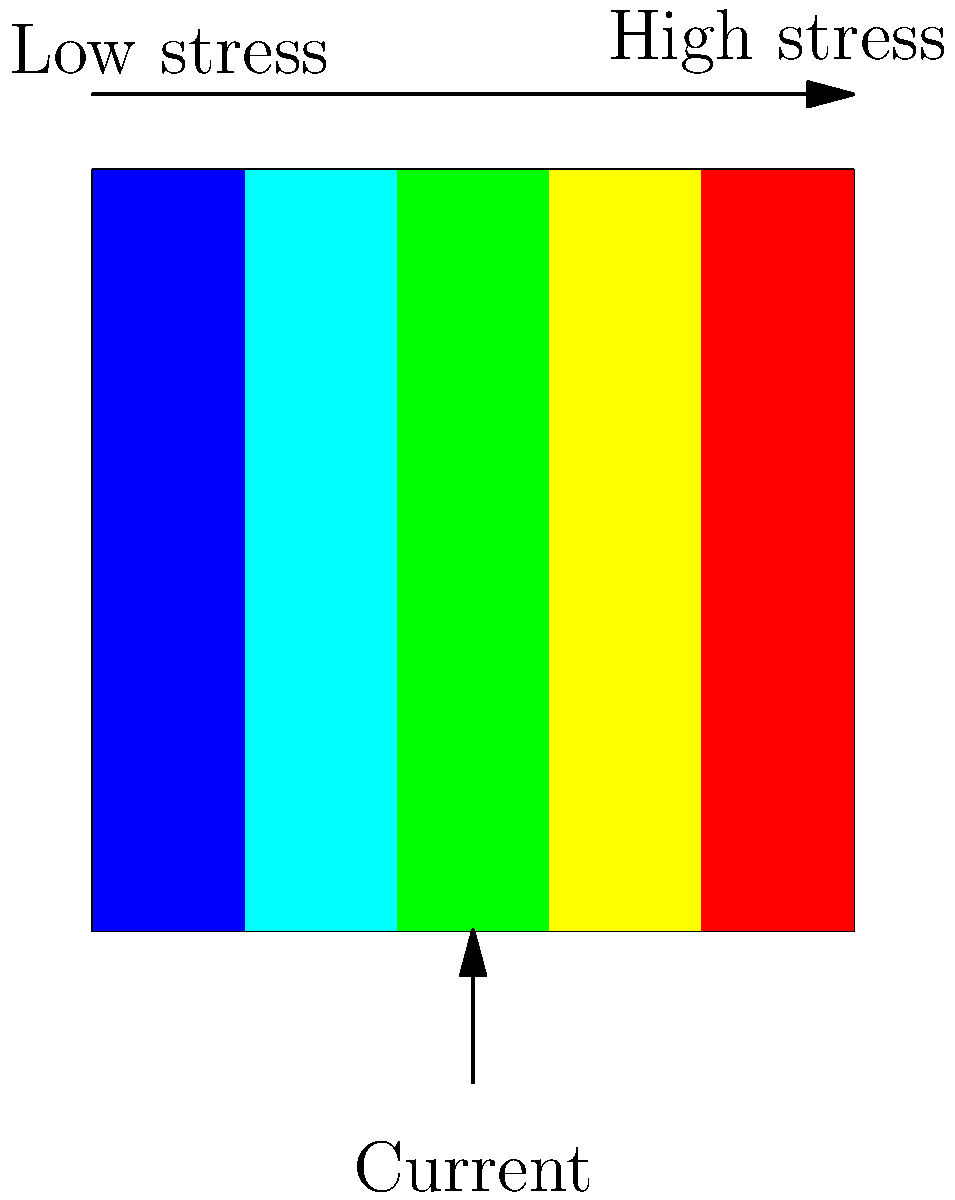Based on the color-coded stress map of an aquaculture net under current conditions, which area of the net experiences the highest mechanical stress, and what measures could be implemented to mitigate potential damage? To answer this question, let's analyze the stress distribution map step-by-step:

1. Color interpretation:
   - The stress map uses a color gradient from blue to red.
   - Blue represents low stress, while red represents high stress.

2. Stress distribution:
   - The color gradient moves from left to right, with blue on the left and red on the right.
   - This indicates that stress increases from left to right across the net.

3. Current direction:
   - The arrow at the bottom shows the current moving from bottom to top.

4. Highest stress area:
   - The rightmost section of the net (colored red) experiences the highest mechanical stress.
   - This is likely due to the cumulative force of the water current as it moves across the net.

5. Potential mitigation measures:
   a) Reinforcement: Strengthen the high-stress area with additional material or support structures.
   b) Net design: Modify the net shape or orientation to distribute stress more evenly.
   c) Current diversion: Implement structures to redirect or reduce current strength in the high-stress area.
   d) Regular monitoring: Implement a routine inspection schedule to detect early signs of wear or damage.
   e) Material selection: Use more durable materials in high-stress areas to increase longevity.

The most effective solution would likely involve a combination of these measures, tailored to the specific conditions of the aquaculture site.
Answer: Rightmost section; reinforce high-stress area, modify net design, divert current, monitor regularly, use durable materials. 